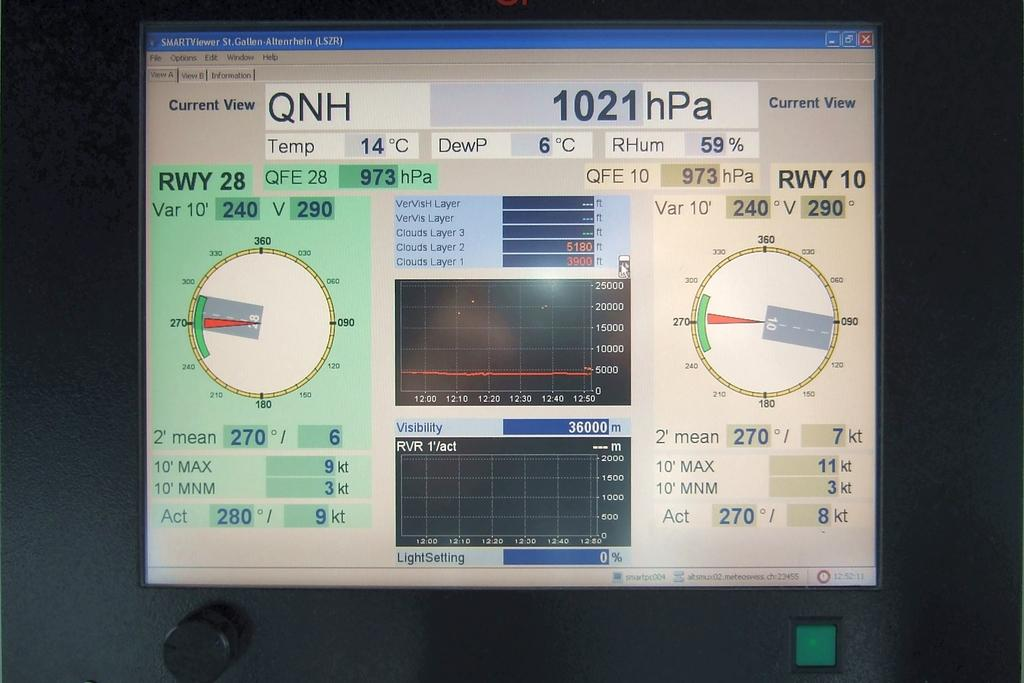<image>
Share a concise interpretation of the image provided. A computer data screen has the numbers 1021 an 973 on it. 